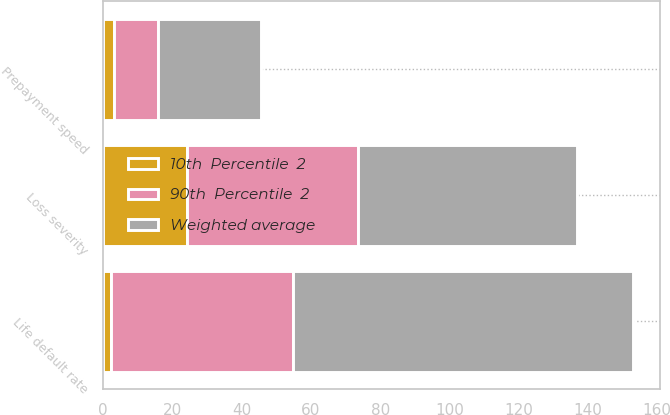Convert chart. <chart><loc_0><loc_0><loc_500><loc_500><stacked_bar_chart><ecel><fcel>Prepayment speed<fcel>Loss severity<fcel>Life default rate<nl><fcel>90th  Percentile  2<fcel>12.9<fcel>49.5<fcel>52.4<nl><fcel>10th  Percentile  2<fcel>3.1<fcel>24.2<fcel>2.4<nl><fcel>Weighted average<fcel>29.7<fcel>63.1<fcel>98.2<nl></chart> 